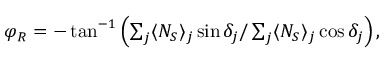<formula> <loc_0><loc_0><loc_500><loc_500>\begin{array} { r } { \varphi _ { R } = - \tan ^ { - 1 } \left ( \sum _ { j } \langle N _ { S } \rangle _ { j } \sin \delta _ { j } / \sum _ { j } \langle N _ { S } \rangle _ { j } \cos \delta _ { j } \right ) , } \end{array}</formula> 